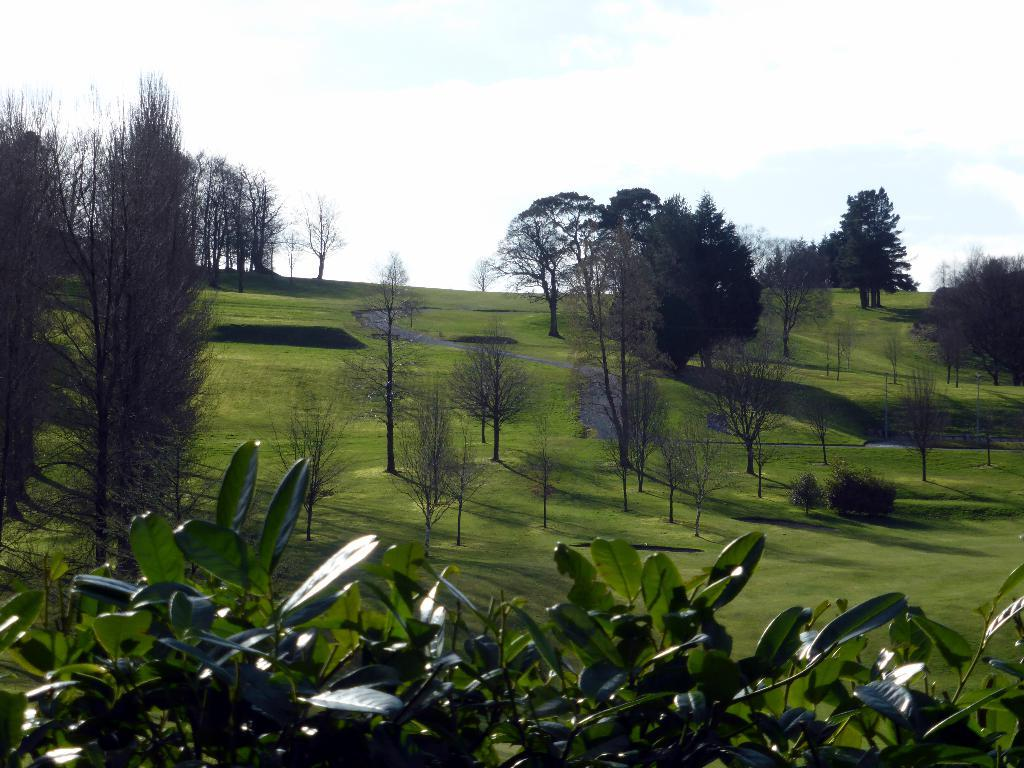What type of vegetation can be seen on the grassland in the image? There are trees on the grassland in the image. What other type of vegetation is present at the bottom of the image? There are plants with leaves at the bottom of the image. What is visible at the top of the image? The sky is visible at the top of the image. What type of bread can be seen on the floor in the image? There is no bread or floor present in the image; it features trees on grassland and plants with leaves. 